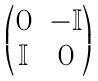Convert formula to latex. <formula><loc_0><loc_0><loc_500><loc_500>\begin{pmatrix} 0 & - { \mathbb { I } } \\ { \mathbb { I } } & 0 \end{pmatrix}</formula> 